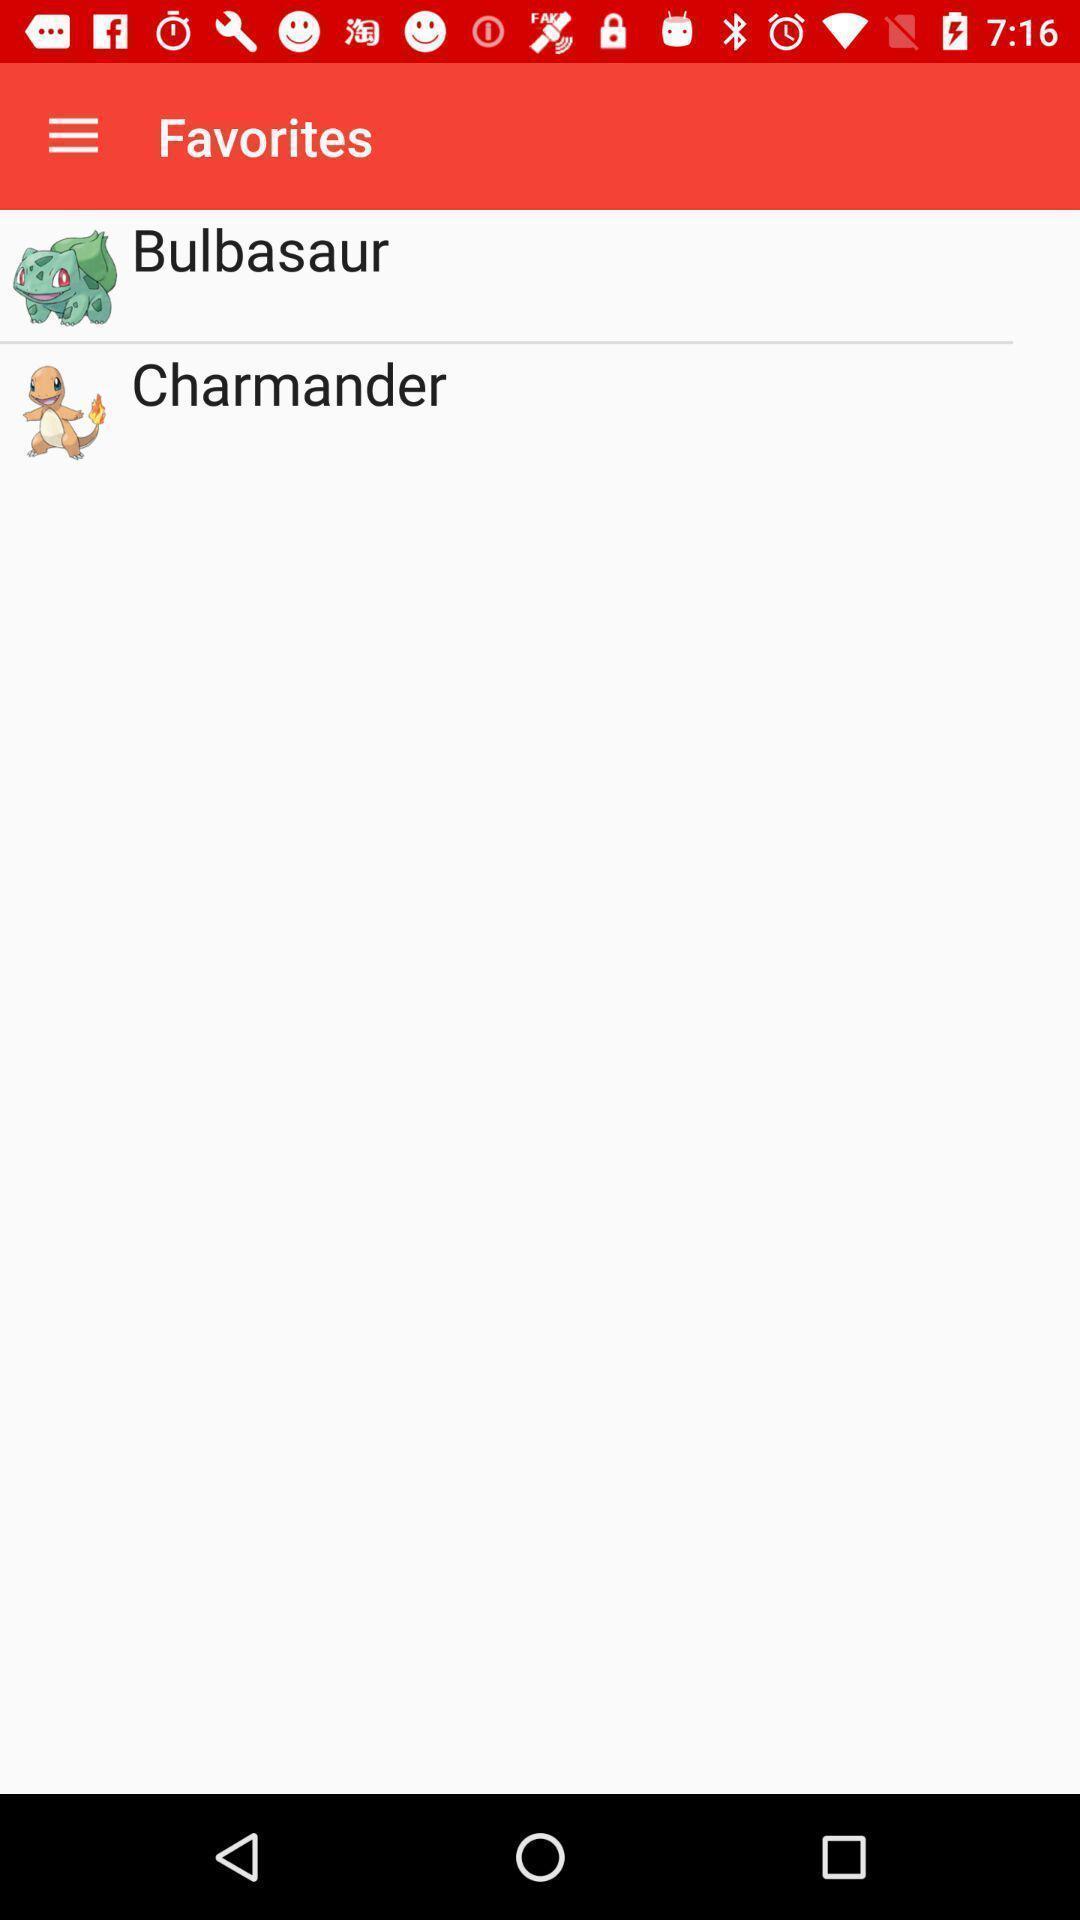Describe the visual elements of this screenshot. Page showing some favorite games. 